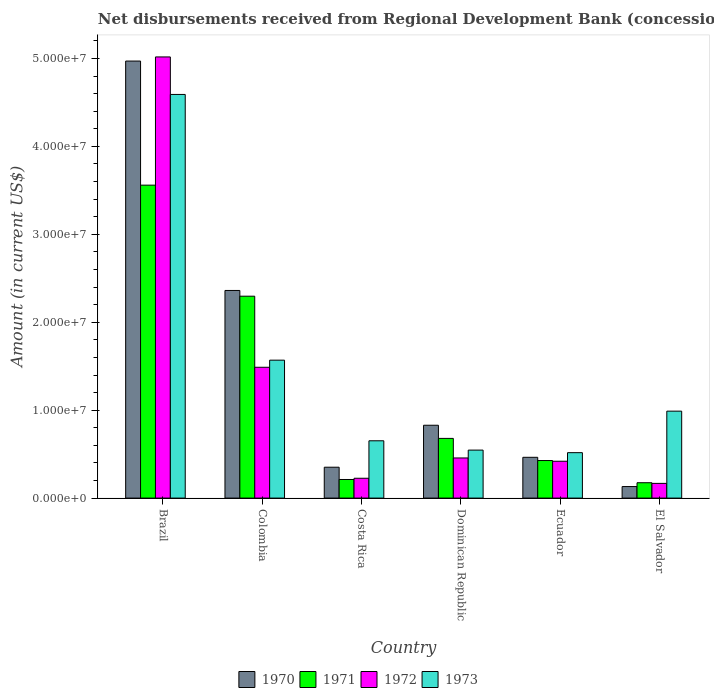How many different coloured bars are there?
Ensure brevity in your answer.  4. How many groups of bars are there?
Provide a succinct answer. 6. Are the number of bars on each tick of the X-axis equal?
Your response must be concise. Yes. How many bars are there on the 6th tick from the left?
Ensure brevity in your answer.  4. How many bars are there on the 6th tick from the right?
Make the answer very short. 4. What is the label of the 6th group of bars from the left?
Your answer should be very brief. El Salvador. What is the amount of disbursements received from Regional Development Bank in 1972 in Colombia?
Provide a short and direct response. 1.49e+07. Across all countries, what is the maximum amount of disbursements received from Regional Development Bank in 1972?
Your response must be concise. 5.02e+07. Across all countries, what is the minimum amount of disbursements received from Regional Development Bank in 1973?
Your answer should be compact. 5.17e+06. In which country was the amount of disbursements received from Regional Development Bank in 1972 maximum?
Your answer should be compact. Brazil. In which country was the amount of disbursements received from Regional Development Bank in 1970 minimum?
Your response must be concise. El Salvador. What is the total amount of disbursements received from Regional Development Bank in 1973 in the graph?
Give a very brief answer. 8.86e+07. What is the difference between the amount of disbursements received from Regional Development Bank in 1971 in Costa Rica and that in Ecuador?
Make the answer very short. -2.16e+06. What is the difference between the amount of disbursements received from Regional Development Bank in 1971 in Brazil and the amount of disbursements received from Regional Development Bank in 1972 in Dominican Republic?
Provide a succinct answer. 3.10e+07. What is the average amount of disbursements received from Regional Development Bank in 1972 per country?
Provide a succinct answer. 1.30e+07. What is the difference between the amount of disbursements received from Regional Development Bank of/in 1970 and amount of disbursements received from Regional Development Bank of/in 1971 in Dominican Republic?
Ensure brevity in your answer.  1.50e+06. What is the ratio of the amount of disbursements received from Regional Development Bank in 1970 in Colombia to that in Ecuador?
Provide a short and direct response. 5.09. Is the amount of disbursements received from Regional Development Bank in 1970 in Brazil less than that in El Salvador?
Provide a short and direct response. No. Is the difference between the amount of disbursements received from Regional Development Bank in 1970 in Colombia and Dominican Republic greater than the difference between the amount of disbursements received from Regional Development Bank in 1971 in Colombia and Dominican Republic?
Offer a very short reply. No. What is the difference between the highest and the second highest amount of disbursements received from Regional Development Bank in 1973?
Provide a succinct answer. 3.60e+07. What is the difference between the highest and the lowest amount of disbursements received from Regional Development Bank in 1970?
Make the answer very short. 4.84e+07. In how many countries, is the amount of disbursements received from Regional Development Bank in 1973 greater than the average amount of disbursements received from Regional Development Bank in 1973 taken over all countries?
Provide a succinct answer. 2. Is it the case that in every country, the sum of the amount of disbursements received from Regional Development Bank in 1970 and amount of disbursements received from Regional Development Bank in 1971 is greater than the sum of amount of disbursements received from Regional Development Bank in 1973 and amount of disbursements received from Regional Development Bank in 1972?
Offer a terse response. No. What does the 3rd bar from the left in El Salvador represents?
Give a very brief answer. 1972. What does the 1st bar from the right in Colombia represents?
Your response must be concise. 1973. How many bars are there?
Offer a very short reply. 24. Are all the bars in the graph horizontal?
Keep it short and to the point. No. How many countries are there in the graph?
Provide a short and direct response. 6. Are the values on the major ticks of Y-axis written in scientific E-notation?
Provide a succinct answer. Yes. Where does the legend appear in the graph?
Keep it short and to the point. Bottom center. How are the legend labels stacked?
Keep it short and to the point. Horizontal. What is the title of the graph?
Keep it short and to the point. Net disbursements received from Regional Development Bank (concessional). Does "1989" appear as one of the legend labels in the graph?
Keep it short and to the point. No. What is the label or title of the Y-axis?
Provide a succinct answer. Amount (in current US$). What is the Amount (in current US$) of 1970 in Brazil?
Provide a succinct answer. 4.97e+07. What is the Amount (in current US$) of 1971 in Brazil?
Your answer should be compact. 3.56e+07. What is the Amount (in current US$) in 1972 in Brazil?
Offer a very short reply. 5.02e+07. What is the Amount (in current US$) of 1973 in Brazil?
Ensure brevity in your answer.  4.59e+07. What is the Amount (in current US$) in 1970 in Colombia?
Your answer should be very brief. 2.36e+07. What is the Amount (in current US$) in 1971 in Colombia?
Provide a short and direct response. 2.30e+07. What is the Amount (in current US$) in 1972 in Colombia?
Make the answer very short. 1.49e+07. What is the Amount (in current US$) of 1973 in Colombia?
Offer a very short reply. 1.57e+07. What is the Amount (in current US$) of 1970 in Costa Rica?
Keep it short and to the point. 3.51e+06. What is the Amount (in current US$) in 1971 in Costa Rica?
Your response must be concise. 2.12e+06. What is the Amount (in current US$) of 1972 in Costa Rica?
Ensure brevity in your answer.  2.26e+06. What is the Amount (in current US$) in 1973 in Costa Rica?
Provide a succinct answer. 6.52e+06. What is the Amount (in current US$) of 1970 in Dominican Republic?
Your answer should be compact. 8.29e+06. What is the Amount (in current US$) in 1971 in Dominican Republic?
Your answer should be very brief. 6.79e+06. What is the Amount (in current US$) in 1972 in Dominican Republic?
Your answer should be very brief. 4.56e+06. What is the Amount (in current US$) in 1973 in Dominican Republic?
Your response must be concise. 5.46e+06. What is the Amount (in current US$) of 1970 in Ecuador?
Keep it short and to the point. 4.64e+06. What is the Amount (in current US$) of 1971 in Ecuador?
Give a very brief answer. 4.27e+06. What is the Amount (in current US$) of 1972 in Ecuador?
Offer a very short reply. 4.19e+06. What is the Amount (in current US$) in 1973 in Ecuador?
Provide a short and direct response. 5.17e+06. What is the Amount (in current US$) in 1970 in El Salvador?
Make the answer very short. 1.31e+06. What is the Amount (in current US$) in 1971 in El Salvador?
Offer a very short reply. 1.75e+06. What is the Amount (in current US$) in 1972 in El Salvador?
Your answer should be very brief. 1.67e+06. What is the Amount (in current US$) in 1973 in El Salvador?
Ensure brevity in your answer.  9.89e+06. Across all countries, what is the maximum Amount (in current US$) of 1970?
Give a very brief answer. 4.97e+07. Across all countries, what is the maximum Amount (in current US$) of 1971?
Provide a short and direct response. 3.56e+07. Across all countries, what is the maximum Amount (in current US$) of 1972?
Your answer should be compact. 5.02e+07. Across all countries, what is the maximum Amount (in current US$) in 1973?
Offer a very short reply. 4.59e+07. Across all countries, what is the minimum Amount (in current US$) in 1970?
Offer a very short reply. 1.31e+06. Across all countries, what is the minimum Amount (in current US$) of 1971?
Offer a very short reply. 1.75e+06. Across all countries, what is the minimum Amount (in current US$) in 1972?
Your answer should be very brief. 1.67e+06. Across all countries, what is the minimum Amount (in current US$) in 1973?
Give a very brief answer. 5.17e+06. What is the total Amount (in current US$) in 1970 in the graph?
Ensure brevity in your answer.  9.11e+07. What is the total Amount (in current US$) in 1971 in the graph?
Your answer should be compact. 7.35e+07. What is the total Amount (in current US$) of 1972 in the graph?
Offer a very short reply. 7.77e+07. What is the total Amount (in current US$) of 1973 in the graph?
Offer a terse response. 8.86e+07. What is the difference between the Amount (in current US$) in 1970 in Brazil and that in Colombia?
Make the answer very short. 2.61e+07. What is the difference between the Amount (in current US$) of 1971 in Brazil and that in Colombia?
Your answer should be very brief. 1.26e+07. What is the difference between the Amount (in current US$) of 1972 in Brazil and that in Colombia?
Provide a short and direct response. 3.53e+07. What is the difference between the Amount (in current US$) of 1973 in Brazil and that in Colombia?
Ensure brevity in your answer.  3.02e+07. What is the difference between the Amount (in current US$) of 1970 in Brazil and that in Costa Rica?
Ensure brevity in your answer.  4.62e+07. What is the difference between the Amount (in current US$) in 1971 in Brazil and that in Costa Rica?
Your answer should be compact. 3.35e+07. What is the difference between the Amount (in current US$) in 1972 in Brazil and that in Costa Rica?
Your answer should be very brief. 4.79e+07. What is the difference between the Amount (in current US$) of 1973 in Brazil and that in Costa Rica?
Keep it short and to the point. 3.94e+07. What is the difference between the Amount (in current US$) of 1970 in Brazil and that in Dominican Republic?
Keep it short and to the point. 4.14e+07. What is the difference between the Amount (in current US$) in 1971 in Brazil and that in Dominican Republic?
Provide a short and direct response. 2.88e+07. What is the difference between the Amount (in current US$) of 1972 in Brazil and that in Dominican Republic?
Offer a terse response. 4.56e+07. What is the difference between the Amount (in current US$) in 1973 in Brazil and that in Dominican Republic?
Offer a terse response. 4.04e+07. What is the difference between the Amount (in current US$) in 1970 in Brazil and that in Ecuador?
Your response must be concise. 4.51e+07. What is the difference between the Amount (in current US$) of 1971 in Brazil and that in Ecuador?
Offer a terse response. 3.13e+07. What is the difference between the Amount (in current US$) of 1972 in Brazil and that in Ecuador?
Provide a short and direct response. 4.60e+07. What is the difference between the Amount (in current US$) in 1973 in Brazil and that in Ecuador?
Give a very brief answer. 4.07e+07. What is the difference between the Amount (in current US$) in 1970 in Brazil and that in El Salvador?
Make the answer very short. 4.84e+07. What is the difference between the Amount (in current US$) of 1971 in Brazil and that in El Salvador?
Provide a short and direct response. 3.38e+07. What is the difference between the Amount (in current US$) in 1972 in Brazil and that in El Salvador?
Ensure brevity in your answer.  4.85e+07. What is the difference between the Amount (in current US$) in 1973 in Brazil and that in El Salvador?
Make the answer very short. 3.60e+07. What is the difference between the Amount (in current US$) of 1970 in Colombia and that in Costa Rica?
Your answer should be very brief. 2.01e+07. What is the difference between the Amount (in current US$) of 1971 in Colombia and that in Costa Rica?
Offer a terse response. 2.08e+07. What is the difference between the Amount (in current US$) of 1972 in Colombia and that in Costa Rica?
Offer a very short reply. 1.26e+07. What is the difference between the Amount (in current US$) in 1973 in Colombia and that in Costa Rica?
Offer a terse response. 9.17e+06. What is the difference between the Amount (in current US$) in 1970 in Colombia and that in Dominican Republic?
Keep it short and to the point. 1.53e+07. What is the difference between the Amount (in current US$) of 1971 in Colombia and that in Dominican Republic?
Ensure brevity in your answer.  1.62e+07. What is the difference between the Amount (in current US$) of 1972 in Colombia and that in Dominican Republic?
Your response must be concise. 1.03e+07. What is the difference between the Amount (in current US$) in 1973 in Colombia and that in Dominican Republic?
Give a very brief answer. 1.02e+07. What is the difference between the Amount (in current US$) of 1970 in Colombia and that in Ecuador?
Provide a short and direct response. 1.90e+07. What is the difference between the Amount (in current US$) of 1971 in Colombia and that in Ecuador?
Ensure brevity in your answer.  1.87e+07. What is the difference between the Amount (in current US$) of 1972 in Colombia and that in Ecuador?
Keep it short and to the point. 1.07e+07. What is the difference between the Amount (in current US$) of 1973 in Colombia and that in Ecuador?
Offer a very short reply. 1.05e+07. What is the difference between the Amount (in current US$) of 1970 in Colombia and that in El Salvador?
Your answer should be very brief. 2.23e+07. What is the difference between the Amount (in current US$) of 1971 in Colombia and that in El Salvador?
Keep it short and to the point. 2.12e+07. What is the difference between the Amount (in current US$) in 1972 in Colombia and that in El Salvador?
Provide a succinct answer. 1.32e+07. What is the difference between the Amount (in current US$) in 1973 in Colombia and that in El Salvador?
Your response must be concise. 5.80e+06. What is the difference between the Amount (in current US$) in 1970 in Costa Rica and that in Dominican Republic?
Offer a very short reply. -4.77e+06. What is the difference between the Amount (in current US$) in 1971 in Costa Rica and that in Dominican Republic?
Offer a terse response. -4.67e+06. What is the difference between the Amount (in current US$) of 1972 in Costa Rica and that in Dominican Republic?
Offer a terse response. -2.31e+06. What is the difference between the Amount (in current US$) of 1973 in Costa Rica and that in Dominican Republic?
Keep it short and to the point. 1.06e+06. What is the difference between the Amount (in current US$) of 1970 in Costa Rica and that in Ecuador?
Keep it short and to the point. -1.13e+06. What is the difference between the Amount (in current US$) in 1971 in Costa Rica and that in Ecuador?
Your response must be concise. -2.16e+06. What is the difference between the Amount (in current US$) of 1972 in Costa Rica and that in Ecuador?
Give a very brief answer. -1.94e+06. What is the difference between the Amount (in current US$) of 1973 in Costa Rica and that in Ecuador?
Offer a terse response. 1.35e+06. What is the difference between the Amount (in current US$) in 1970 in Costa Rica and that in El Salvador?
Make the answer very short. 2.20e+06. What is the difference between the Amount (in current US$) in 1971 in Costa Rica and that in El Salvador?
Your answer should be very brief. 3.69e+05. What is the difference between the Amount (in current US$) in 1972 in Costa Rica and that in El Salvador?
Your answer should be very brief. 5.83e+05. What is the difference between the Amount (in current US$) of 1973 in Costa Rica and that in El Salvador?
Provide a short and direct response. -3.37e+06. What is the difference between the Amount (in current US$) of 1970 in Dominican Republic and that in Ecuador?
Offer a very short reply. 3.65e+06. What is the difference between the Amount (in current US$) in 1971 in Dominican Republic and that in Ecuador?
Offer a very short reply. 2.52e+06. What is the difference between the Amount (in current US$) of 1972 in Dominican Republic and that in Ecuador?
Offer a terse response. 3.74e+05. What is the difference between the Amount (in current US$) in 1973 in Dominican Republic and that in Ecuador?
Your response must be concise. 2.92e+05. What is the difference between the Amount (in current US$) in 1970 in Dominican Republic and that in El Salvador?
Ensure brevity in your answer.  6.97e+06. What is the difference between the Amount (in current US$) of 1971 in Dominican Republic and that in El Salvador?
Keep it short and to the point. 5.04e+06. What is the difference between the Amount (in current US$) of 1972 in Dominican Republic and that in El Salvador?
Ensure brevity in your answer.  2.89e+06. What is the difference between the Amount (in current US$) in 1973 in Dominican Republic and that in El Salvador?
Offer a terse response. -4.43e+06. What is the difference between the Amount (in current US$) of 1970 in Ecuador and that in El Salvador?
Your answer should be compact. 3.33e+06. What is the difference between the Amount (in current US$) of 1971 in Ecuador and that in El Salvador?
Make the answer very short. 2.52e+06. What is the difference between the Amount (in current US$) in 1972 in Ecuador and that in El Salvador?
Your response must be concise. 2.52e+06. What is the difference between the Amount (in current US$) in 1973 in Ecuador and that in El Salvador?
Your answer should be very brief. -4.72e+06. What is the difference between the Amount (in current US$) of 1970 in Brazil and the Amount (in current US$) of 1971 in Colombia?
Offer a very short reply. 2.67e+07. What is the difference between the Amount (in current US$) in 1970 in Brazil and the Amount (in current US$) in 1972 in Colombia?
Give a very brief answer. 3.48e+07. What is the difference between the Amount (in current US$) in 1970 in Brazil and the Amount (in current US$) in 1973 in Colombia?
Your response must be concise. 3.40e+07. What is the difference between the Amount (in current US$) in 1971 in Brazil and the Amount (in current US$) in 1972 in Colombia?
Make the answer very short. 2.07e+07. What is the difference between the Amount (in current US$) in 1971 in Brazil and the Amount (in current US$) in 1973 in Colombia?
Your response must be concise. 1.99e+07. What is the difference between the Amount (in current US$) in 1972 in Brazil and the Amount (in current US$) in 1973 in Colombia?
Offer a terse response. 3.45e+07. What is the difference between the Amount (in current US$) of 1970 in Brazil and the Amount (in current US$) of 1971 in Costa Rica?
Offer a terse response. 4.76e+07. What is the difference between the Amount (in current US$) in 1970 in Brazil and the Amount (in current US$) in 1972 in Costa Rica?
Your answer should be compact. 4.75e+07. What is the difference between the Amount (in current US$) in 1970 in Brazil and the Amount (in current US$) in 1973 in Costa Rica?
Your answer should be compact. 4.32e+07. What is the difference between the Amount (in current US$) in 1971 in Brazil and the Amount (in current US$) in 1972 in Costa Rica?
Your answer should be compact. 3.33e+07. What is the difference between the Amount (in current US$) of 1971 in Brazil and the Amount (in current US$) of 1973 in Costa Rica?
Provide a succinct answer. 2.91e+07. What is the difference between the Amount (in current US$) in 1972 in Brazil and the Amount (in current US$) in 1973 in Costa Rica?
Your response must be concise. 4.37e+07. What is the difference between the Amount (in current US$) in 1970 in Brazil and the Amount (in current US$) in 1971 in Dominican Republic?
Your answer should be compact. 4.29e+07. What is the difference between the Amount (in current US$) in 1970 in Brazil and the Amount (in current US$) in 1972 in Dominican Republic?
Your response must be concise. 4.51e+07. What is the difference between the Amount (in current US$) in 1970 in Brazil and the Amount (in current US$) in 1973 in Dominican Republic?
Ensure brevity in your answer.  4.42e+07. What is the difference between the Amount (in current US$) of 1971 in Brazil and the Amount (in current US$) of 1972 in Dominican Republic?
Your answer should be compact. 3.10e+07. What is the difference between the Amount (in current US$) of 1971 in Brazil and the Amount (in current US$) of 1973 in Dominican Republic?
Your response must be concise. 3.01e+07. What is the difference between the Amount (in current US$) of 1972 in Brazil and the Amount (in current US$) of 1973 in Dominican Republic?
Offer a very short reply. 4.47e+07. What is the difference between the Amount (in current US$) of 1970 in Brazil and the Amount (in current US$) of 1971 in Ecuador?
Keep it short and to the point. 4.54e+07. What is the difference between the Amount (in current US$) in 1970 in Brazil and the Amount (in current US$) in 1972 in Ecuador?
Your answer should be compact. 4.55e+07. What is the difference between the Amount (in current US$) in 1970 in Brazil and the Amount (in current US$) in 1973 in Ecuador?
Ensure brevity in your answer.  4.45e+07. What is the difference between the Amount (in current US$) in 1971 in Brazil and the Amount (in current US$) in 1972 in Ecuador?
Provide a short and direct response. 3.14e+07. What is the difference between the Amount (in current US$) in 1971 in Brazil and the Amount (in current US$) in 1973 in Ecuador?
Give a very brief answer. 3.04e+07. What is the difference between the Amount (in current US$) of 1972 in Brazil and the Amount (in current US$) of 1973 in Ecuador?
Provide a short and direct response. 4.50e+07. What is the difference between the Amount (in current US$) in 1970 in Brazil and the Amount (in current US$) in 1971 in El Salvador?
Offer a very short reply. 4.80e+07. What is the difference between the Amount (in current US$) of 1970 in Brazil and the Amount (in current US$) of 1972 in El Salvador?
Give a very brief answer. 4.80e+07. What is the difference between the Amount (in current US$) in 1970 in Brazil and the Amount (in current US$) in 1973 in El Salvador?
Provide a short and direct response. 3.98e+07. What is the difference between the Amount (in current US$) of 1971 in Brazil and the Amount (in current US$) of 1972 in El Salvador?
Give a very brief answer. 3.39e+07. What is the difference between the Amount (in current US$) of 1971 in Brazil and the Amount (in current US$) of 1973 in El Salvador?
Provide a succinct answer. 2.57e+07. What is the difference between the Amount (in current US$) of 1972 in Brazil and the Amount (in current US$) of 1973 in El Salvador?
Offer a terse response. 4.03e+07. What is the difference between the Amount (in current US$) of 1970 in Colombia and the Amount (in current US$) of 1971 in Costa Rica?
Your answer should be very brief. 2.15e+07. What is the difference between the Amount (in current US$) in 1970 in Colombia and the Amount (in current US$) in 1972 in Costa Rica?
Offer a terse response. 2.14e+07. What is the difference between the Amount (in current US$) of 1970 in Colombia and the Amount (in current US$) of 1973 in Costa Rica?
Keep it short and to the point. 1.71e+07. What is the difference between the Amount (in current US$) of 1971 in Colombia and the Amount (in current US$) of 1972 in Costa Rica?
Give a very brief answer. 2.07e+07. What is the difference between the Amount (in current US$) in 1971 in Colombia and the Amount (in current US$) in 1973 in Costa Rica?
Make the answer very short. 1.64e+07. What is the difference between the Amount (in current US$) in 1972 in Colombia and the Amount (in current US$) in 1973 in Costa Rica?
Your answer should be compact. 8.36e+06. What is the difference between the Amount (in current US$) in 1970 in Colombia and the Amount (in current US$) in 1971 in Dominican Republic?
Your answer should be compact. 1.68e+07. What is the difference between the Amount (in current US$) of 1970 in Colombia and the Amount (in current US$) of 1972 in Dominican Republic?
Offer a very short reply. 1.90e+07. What is the difference between the Amount (in current US$) in 1970 in Colombia and the Amount (in current US$) in 1973 in Dominican Republic?
Offer a terse response. 1.82e+07. What is the difference between the Amount (in current US$) in 1971 in Colombia and the Amount (in current US$) in 1972 in Dominican Republic?
Your answer should be compact. 1.84e+07. What is the difference between the Amount (in current US$) of 1971 in Colombia and the Amount (in current US$) of 1973 in Dominican Republic?
Provide a succinct answer. 1.75e+07. What is the difference between the Amount (in current US$) in 1972 in Colombia and the Amount (in current US$) in 1973 in Dominican Republic?
Provide a short and direct response. 9.42e+06. What is the difference between the Amount (in current US$) of 1970 in Colombia and the Amount (in current US$) of 1971 in Ecuador?
Make the answer very short. 1.93e+07. What is the difference between the Amount (in current US$) of 1970 in Colombia and the Amount (in current US$) of 1972 in Ecuador?
Keep it short and to the point. 1.94e+07. What is the difference between the Amount (in current US$) in 1970 in Colombia and the Amount (in current US$) in 1973 in Ecuador?
Provide a succinct answer. 1.84e+07. What is the difference between the Amount (in current US$) in 1971 in Colombia and the Amount (in current US$) in 1972 in Ecuador?
Make the answer very short. 1.88e+07. What is the difference between the Amount (in current US$) in 1971 in Colombia and the Amount (in current US$) in 1973 in Ecuador?
Offer a very short reply. 1.78e+07. What is the difference between the Amount (in current US$) of 1972 in Colombia and the Amount (in current US$) of 1973 in Ecuador?
Offer a terse response. 9.71e+06. What is the difference between the Amount (in current US$) of 1970 in Colombia and the Amount (in current US$) of 1971 in El Salvador?
Your response must be concise. 2.19e+07. What is the difference between the Amount (in current US$) in 1970 in Colombia and the Amount (in current US$) in 1972 in El Salvador?
Your answer should be compact. 2.19e+07. What is the difference between the Amount (in current US$) of 1970 in Colombia and the Amount (in current US$) of 1973 in El Salvador?
Provide a short and direct response. 1.37e+07. What is the difference between the Amount (in current US$) of 1971 in Colombia and the Amount (in current US$) of 1972 in El Salvador?
Your response must be concise. 2.13e+07. What is the difference between the Amount (in current US$) in 1971 in Colombia and the Amount (in current US$) in 1973 in El Salvador?
Your answer should be compact. 1.31e+07. What is the difference between the Amount (in current US$) in 1972 in Colombia and the Amount (in current US$) in 1973 in El Salvador?
Your answer should be compact. 4.99e+06. What is the difference between the Amount (in current US$) of 1970 in Costa Rica and the Amount (in current US$) of 1971 in Dominican Republic?
Provide a short and direct response. -3.28e+06. What is the difference between the Amount (in current US$) in 1970 in Costa Rica and the Amount (in current US$) in 1972 in Dominican Republic?
Offer a terse response. -1.05e+06. What is the difference between the Amount (in current US$) of 1970 in Costa Rica and the Amount (in current US$) of 1973 in Dominican Republic?
Keep it short and to the point. -1.95e+06. What is the difference between the Amount (in current US$) in 1971 in Costa Rica and the Amount (in current US$) in 1972 in Dominican Republic?
Make the answer very short. -2.45e+06. What is the difference between the Amount (in current US$) of 1971 in Costa Rica and the Amount (in current US$) of 1973 in Dominican Republic?
Your answer should be very brief. -3.34e+06. What is the difference between the Amount (in current US$) of 1972 in Costa Rica and the Amount (in current US$) of 1973 in Dominican Republic?
Give a very brief answer. -3.20e+06. What is the difference between the Amount (in current US$) of 1970 in Costa Rica and the Amount (in current US$) of 1971 in Ecuador?
Your answer should be very brief. -7.58e+05. What is the difference between the Amount (in current US$) of 1970 in Costa Rica and the Amount (in current US$) of 1972 in Ecuador?
Your response must be concise. -6.78e+05. What is the difference between the Amount (in current US$) in 1970 in Costa Rica and the Amount (in current US$) in 1973 in Ecuador?
Ensure brevity in your answer.  -1.65e+06. What is the difference between the Amount (in current US$) of 1971 in Costa Rica and the Amount (in current US$) of 1972 in Ecuador?
Keep it short and to the point. -2.08e+06. What is the difference between the Amount (in current US$) of 1971 in Costa Rica and the Amount (in current US$) of 1973 in Ecuador?
Keep it short and to the point. -3.05e+06. What is the difference between the Amount (in current US$) in 1972 in Costa Rica and the Amount (in current US$) in 1973 in Ecuador?
Your response must be concise. -2.91e+06. What is the difference between the Amount (in current US$) of 1970 in Costa Rica and the Amount (in current US$) of 1971 in El Salvador?
Your response must be concise. 1.77e+06. What is the difference between the Amount (in current US$) in 1970 in Costa Rica and the Amount (in current US$) in 1972 in El Salvador?
Your answer should be very brief. 1.84e+06. What is the difference between the Amount (in current US$) in 1970 in Costa Rica and the Amount (in current US$) in 1973 in El Salvador?
Make the answer very short. -6.38e+06. What is the difference between the Amount (in current US$) of 1971 in Costa Rica and the Amount (in current US$) of 1972 in El Salvador?
Make the answer very short. 4.43e+05. What is the difference between the Amount (in current US$) of 1971 in Costa Rica and the Amount (in current US$) of 1973 in El Salvador?
Make the answer very short. -7.77e+06. What is the difference between the Amount (in current US$) of 1972 in Costa Rica and the Amount (in current US$) of 1973 in El Salvador?
Your answer should be compact. -7.63e+06. What is the difference between the Amount (in current US$) in 1970 in Dominican Republic and the Amount (in current US$) in 1971 in Ecuador?
Your answer should be compact. 4.02e+06. What is the difference between the Amount (in current US$) in 1970 in Dominican Republic and the Amount (in current US$) in 1972 in Ecuador?
Ensure brevity in your answer.  4.10e+06. What is the difference between the Amount (in current US$) of 1970 in Dominican Republic and the Amount (in current US$) of 1973 in Ecuador?
Provide a short and direct response. 3.12e+06. What is the difference between the Amount (in current US$) of 1971 in Dominican Republic and the Amount (in current US$) of 1972 in Ecuador?
Your answer should be very brief. 2.60e+06. What is the difference between the Amount (in current US$) in 1971 in Dominican Republic and the Amount (in current US$) in 1973 in Ecuador?
Provide a succinct answer. 1.62e+06. What is the difference between the Amount (in current US$) of 1972 in Dominican Republic and the Amount (in current US$) of 1973 in Ecuador?
Offer a very short reply. -6.02e+05. What is the difference between the Amount (in current US$) of 1970 in Dominican Republic and the Amount (in current US$) of 1971 in El Salvador?
Your answer should be very brief. 6.54e+06. What is the difference between the Amount (in current US$) in 1970 in Dominican Republic and the Amount (in current US$) in 1972 in El Salvador?
Make the answer very short. 6.61e+06. What is the difference between the Amount (in current US$) of 1970 in Dominican Republic and the Amount (in current US$) of 1973 in El Salvador?
Give a very brief answer. -1.60e+06. What is the difference between the Amount (in current US$) in 1971 in Dominican Republic and the Amount (in current US$) in 1972 in El Salvador?
Offer a terse response. 5.12e+06. What is the difference between the Amount (in current US$) of 1971 in Dominican Republic and the Amount (in current US$) of 1973 in El Salvador?
Provide a succinct answer. -3.10e+06. What is the difference between the Amount (in current US$) of 1972 in Dominican Republic and the Amount (in current US$) of 1973 in El Salvador?
Ensure brevity in your answer.  -5.32e+06. What is the difference between the Amount (in current US$) of 1970 in Ecuador and the Amount (in current US$) of 1971 in El Salvador?
Make the answer very short. 2.89e+06. What is the difference between the Amount (in current US$) in 1970 in Ecuador and the Amount (in current US$) in 1972 in El Salvador?
Your response must be concise. 2.97e+06. What is the difference between the Amount (in current US$) in 1970 in Ecuador and the Amount (in current US$) in 1973 in El Salvador?
Your answer should be very brief. -5.25e+06. What is the difference between the Amount (in current US$) in 1971 in Ecuador and the Amount (in current US$) in 1972 in El Salvador?
Your answer should be compact. 2.60e+06. What is the difference between the Amount (in current US$) of 1971 in Ecuador and the Amount (in current US$) of 1973 in El Salvador?
Keep it short and to the point. -5.62e+06. What is the difference between the Amount (in current US$) in 1972 in Ecuador and the Amount (in current US$) in 1973 in El Salvador?
Provide a succinct answer. -5.70e+06. What is the average Amount (in current US$) of 1970 per country?
Provide a short and direct response. 1.52e+07. What is the average Amount (in current US$) of 1971 per country?
Make the answer very short. 1.22e+07. What is the average Amount (in current US$) in 1972 per country?
Make the answer very short. 1.30e+07. What is the average Amount (in current US$) in 1973 per country?
Ensure brevity in your answer.  1.48e+07. What is the difference between the Amount (in current US$) of 1970 and Amount (in current US$) of 1971 in Brazil?
Your answer should be compact. 1.41e+07. What is the difference between the Amount (in current US$) in 1970 and Amount (in current US$) in 1972 in Brazil?
Make the answer very short. -4.68e+05. What is the difference between the Amount (in current US$) in 1970 and Amount (in current US$) in 1973 in Brazil?
Offer a very short reply. 3.80e+06. What is the difference between the Amount (in current US$) in 1971 and Amount (in current US$) in 1972 in Brazil?
Offer a very short reply. -1.46e+07. What is the difference between the Amount (in current US$) of 1971 and Amount (in current US$) of 1973 in Brazil?
Your response must be concise. -1.03e+07. What is the difference between the Amount (in current US$) in 1972 and Amount (in current US$) in 1973 in Brazil?
Provide a short and direct response. 4.27e+06. What is the difference between the Amount (in current US$) of 1970 and Amount (in current US$) of 1971 in Colombia?
Offer a very short reply. 6.52e+05. What is the difference between the Amount (in current US$) of 1970 and Amount (in current US$) of 1972 in Colombia?
Give a very brief answer. 8.74e+06. What is the difference between the Amount (in current US$) of 1970 and Amount (in current US$) of 1973 in Colombia?
Offer a terse response. 7.93e+06. What is the difference between the Amount (in current US$) of 1971 and Amount (in current US$) of 1972 in Colombia?
Ensure brevity in your answer.  8.08e+06. What is the difference between the Amount (in current US$) of 1971 and Amount (in current US$) of 1973 in Colombia?
Provide a short and direct response. 7.28e+06. What is the difference between the Amount (in current US$) of 1972 and Amount (in current US$) of 1973 in Colombia?
Offer a very short reply. -8.09e+05. What is the difference between the Amount (in current US$) in 1970 and Amount (in current US$) in 1971 in Costa Rica?
Offer a terse response. 1.40e+06. What is the difference between the Amount (in current US$) of 1970 and Amount (in current US$) of 1972 in Costa Rica?
Your answer should be very brief. 1.26e+06. What is the difference between the Amount (in current US$) in 1970 and Amount (in current US$) in 1973 in Costa Rica?
Provide a short and direct response. -3.00e+06. What is the difference between the Amount (in current US$) of 1971 and Amount (in current US$) of 1973 in Costa Rica?
Ensure brevity in your answer.  -4.40e+06. What is the difference between the Amount (in current US$) of 1972 and Amount (in current US$) of 1973 in Costa Rica?
Provide a succinct answer. -4.26e+06. What is the difference between the Amount (in current US$) in 1970 and Amount (in current US$) in 1971 in Dominican Republic?
Offer a terse response. 1.50e+06. What is the difference between the Amount (in current US$) in 1970 and Amount (in current US$) in 1972 in Dominican Republic?
Keep it short and to the point. 3.72e+06. What is the difference between the Amount (in current US$) in 1970 and Amount (in current US$) in 1973 in Dominican Republic?
Your response must be concise. 2.83e+06. What is the difference between the Amount (in current US$) of 1971 and Amount (in current US$) of 1972 in Dominican Republic?
Give a very brief answer. 2.22e+06. What is the difference between the Amount (in current US$) of 1971 and Amount (in current US$) of 1973 in Dominican Republic?
Make the answer very short. 1.33e+06. What is the difference between the Amount (in current US$) in 1972 and Amount (in current US$) in 1973 in Dominican Republic?
Provide a succinct answer. -8.94e+05. What is the difference between the Amount (in current US$) in 1970 and Amount (in current US$) in 1971 in Ecuador?
Your answer should be compact. 3.68e+05. What is the difference between the Amount (in current US$) in 1970 and Amount (in current US$) in 1972 in Ecuador?
Ensure brevity in your answer.  4.48e+05. What is the difference between the Amount (in current US$) of 1970 and Amount (in current US$) of 1973 in Ecuador?
Your answer should be very brief. -5.28e+05. What is the difference between the Amount (in current US$) in 1971 and Amount (in current US$) in 1973 in Ecuador?
Offer a very short reply. -8.96e+05. What is the difference between the Amount (in current US$) in 1972 and Amount (in current US$) in 1973 in Ecuador?
Make the answer very short. -9.76e+05. What is the difference between the Amount (in current US$) in 1970 and Amount (in current US$) in 1971 in El Salvador?
Give a very brief answer. -4.34e+05. What is the difference between the Amount (in current US$) of 1970 and Amount (in current US$) of 1972 in El Salvador?
Provide a succinct answer. -3.60e+05. What is the difference between the Amount (in current US$) of 1970 and Amount (in current US$) of 1973 in El Salvador?
Your answer should be compact. -8.58e+06. What is the difference between the Amount (in current US$) of 1971 and Amount (in current US$) of 1972 in El Salvador?
Your response must be concise. 7.40e+04. What is the difference between the Amount (in current US$) of 1971 and Amount (in current US$) of 1973 in El Salvador?
Keep it short and to the point. -8.14e+06. What is the difference between the Amount (in current US$) of 1972 and Amount (in current US$) of 1973 in El Salvador?
Offer a very short reply. -8.22e+06. What is the ratio of the Amount (in current US$) in 1970 in Brazil to that in Colombia?
Provide a short and direct response. 2.1. What is the ratio of the Amount (in current US$) of 1971 in Brazil to that in Colombia?
Provide a succinct answer. 1.55. What is the ratio of the Amount (in current US$) in 1972 in Brazil to that in Colombia?
Provide a short and direct response. 3.37. What is the ratio of the Amount (in current US$) in 1973 in Brazil to that in Colombia?
Provide a succinct answer. 2.93. What is the ratio of the Amount (in current US$) of 1970 in Brazil to that in Costa Rica?
Your response must be concise. 14.15. What is the ratio of the Amount (in current US$) in 1971 in Brazil to that in Costa Rica?
Keep it short and to the point. 16.82. What is the ratio of the Amount (in current US$) in 1972 in Brazil to that in Costa Rica?
Your response must be concise. 22.24. What is the ratio of the Amount (in current US$) of 1973 in Brazil to that in Costa Rica?
Provide a succinct answer. 7.04. What is the ratio of the Amount (in current US$) of 1970 in Brazil to that in Dominican Republic?
Ensure brevity in your answer.  6. What is the ratio of the Amount (in current US$) in 1971 in Brazil to that in Dominican Republic?
Keep it short and to the point. 5.24. What is the ratio of the Amount (in current US$) of 1972 in Brazil to that in Dominican Republic?
Your answer should be very brief. 10.99. What is the ratio of the Amount (in current US$) of 1973 in Brazil to that in Dominican Republic?
Give a very brief answer. 8.41. What is the ratio of the Amount (in current US$) in 1970 in Brazil to that in Ecuador?
Your response must be concise. 10.72. What is the ratio of the Amount (in current US$) in 1971 in Brazil to that in Ecuador?
Keep it short and to the point. 8.33. What is the ratio of the Amount (in current US$) in 1972 in Brazil to that in Ecuador?
Ensure brevity in your answer.  11.97. What is the ratio of the Amount (in current US$) of 1973 in Brazil to that in Ecuador?
Provide a succinct answer. 8.88. What is the ratio of the Amount (in current US$) in 1970 in Brazil to that in El Salvador?
Provide a short and direct response. 37.86. What is the ratio of the Amount (in current US$) in 1971 in Brazil to that in El Salvador?
Your answer should be very brief. 20.37. What is the ratio of the Amount (in current US$) of 1972 in Brazil to that in El Salvador?
Provide a short and direct response. 29.99. What is the ratio of the Amount (in current US$) in 1973 in Brazil to that in El Salvador?
Your answer should be very brief. 4.64. What is the ratio of the Amount (in current US$) in 1970 in Colombia to that in Costa Rica?
Provide a short and direct response. 6.72. What is the ratio of the Amount (in current US$) of 1971 in Colombia to that in Costa Rica?
Give a very brief answer. 10.85. What is the ratio of the Amount (in current US$) in 1972 in Colombia to that in Costa Rica?
Provide a short and direct response. 6.59. What is the ratio of the Amount (in current US$) of 1973 in Colombia to that in Costa Rica?
Your answer should be compact. 2.41. What is the ratio of the Amount (in current US$) of 1970 in Colombia to that in Dominican Republic?
Keep it short and to the point. 2.85. What is the ratio of the Amount (in current US$) in 1971 in Colombia to that in Dominican Republic?
Give a very brief answer. 3.38. What is the ratio of the Amount (in current US$) of 1972 in Colombia to that in Dominican Republic?
Provide a succinct answer. 3.26. What is the ratio of the Amount (in current US$) of 1973 in Colombia to that in Dominican Republic?
Offer a very short reply. 2.87. What is the ratio of the Amount (in current US$) of 1970 in Colombia to that in Ecuador?
Your answer should be very brief. 5.09. What is the ratio of the Amount (in current US$) in 1971 in Colombia to that in Ecuador?
Your response must be concise. 5.38. What is the ratio of the Amount (in current US$) of 1972 in Colombia to that in Ecuador?
Your response must be concise. 3.55. What is the ratio of the Amount (in current US$) of 1973 in Colombia to that in Ecuador?
Offer a terse response. 3.04. What is the ratio of the Amount (in current US$) in 1970 in Colombia to that in El Salvador?
Give a very brief answer. 17.99. What is the ratio of the Amount (in current US$) in 1971 in Colombia to that in El Salvador?
Provide a succinct answer. 13.14. What is the ratio of the Amount (in current US$) of 1972 in Colombia to that in El Salvador?
Give a very brief answer. 8.89. What is the ratio of the Amount (in current US$) of 1973 in Colombia to that in El Salvador?
Your answer should be compact. 1.59. What is the ratio of the Amount (in current US$) in 1970 in Costa Rica to that in Dominican Republic?
Offer a very short reply. 0.42. What is the ratio of the Amount (in current US$) of 1971 in Costa Rica to that in Dominican Republic?
Give a very brief answer. 0.31. What is the ratio of the Amount (in current US$) in 1972 in Costa Rica to that in Dominican Republic?
Offer a very short reply. 0.49. What is the ratio of the Amount (in current US$) of 1973 in Costa Rica to that in Dominican Republic?
Your answer should be compact. 1.19. What is the ratio of the Amount (in current US$) in 1970 in Costa Rica to that in Ecuador?
Give a very brief answer. 0.76. What is the ratio of the Amount (in current US$) in 1971 in Costa Rica to that in Ecuador?
Provide a short and direct response. 0.5. What is the ratio of the Amount (in current US$) in 1972 in Costa Rica to that in Ecuador?
Offer a very short reply. 0.54. What is the ratio of the Amount (in current US$) of 1973 in Costa Rica to that in Ecuador?
Ensure brevity in your answer.  1.26. What is the ratio of the Amount (in current US$) of 1970 in Costa Rica to that in El Salvador?
Your answer should be very brief. 2.68. What is the ratio of the Amount (in current US$) of 1971 in Costa Rica to that in El Salvador?
Your answer should be compact. 1.21. What is the ratio of the Amount (in current US$) in 1972 in Costa Rica to that in El Salvador?
Offer a very short reply. 1.35. What is the ratio of the Amount (in current US$) in 1973 in Costa Rica to that in El Salvador?
Your response must be concise. 0.66. What is the ratio of the Amount (in current US$) of 1970 in Dominican Republic to that in Ecuador?
Offer a terse response. 1.79. What is the ratio of the Amount (in current US$) in 1971 in Dominican Republic to that in Ecuador?
Your response must be concise. 1.59. What is the ratio of the Amount (in current US$) in 1972 in Dominican Republic to that in Ecuador?
Ensure brevity in your answer.  1.09. What is the ratio of the Amount (in current US$) in 1973 in Dominican Republic to that in Ecuador?
Provide a succinct answer. 1.06. What is the ratio of the Amount (in current US$) of 1970 in Dominican Republic to that in El Salvador?
Provide a short and direct response. 6.31. What is the ratio of the Amount (in current US$) of 1971 in Dominican Republic to that in El Salvador?
Give a very brief answer. 3.89. What is the ratio of the Amount (in current US$) in 1972 in Dominican Republic to that in El Salvador?
Provide a succinct answer. 2.73. What is the ratio of the Amount (in current US$) in 1973 in Dominican Republic to that in El Salvador?
Your response must be concise. 0.55. What is the ratio of the Amount (in current US$) of 1970 in Ecuador to that in El Salvador?
Provide a short and direct response. 3.53. What is the ratio of the Amount (in current US$) of 1971 in Ecuador to that in El Salvador?
Your response must be concise. 2.44. What is the ratio of the Amount (in current US$) of 1972 in Ecuador to that in El Salvador?
Your answer should be very brief. 2.51. What is the ratio of the Amount (in current US$) in 1973 in Ecuador to that in El Salvador?
Offer a terse response. 0.52. What is the difference between the highest and the second highest Amount (in current US$) of 1970?
Give a very brief answer. 2.61e+07. What is the difference between the highest and the second highest Amount (in current US$) in 1971?
Provide a short and direct response. 1.26e+07. What is the difference between the highest and the second highest Amount (in current US$) in 1972?
Offer a terse response. 3.53e+07. What is the difference between the highest and the second highest Amount (in current US$) in 1973?
Ensure brevity in your answer.  3.02e+07. What is the difference between the highest and the lowest Amount (in current US$) of 1970?
Provide a short and direct response. 4.84e+07. What is the difference between the highest and the lowest Amount (in current US$) in 1971?
Offer a terse response. 3.38e+07. What is the difference between the highest and the lowest Amount (in current US$) in 1972?
Your answer should be very brief. 4.85e+07. What is the difference between the highest and the lowest Amount (in current US$) of 1973?
Offer a terse response. 4.07e+07. 